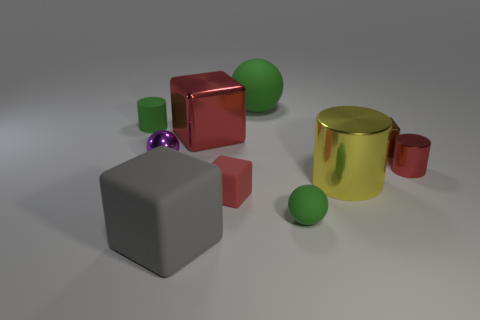How many yellow cylinders are made of the same material as the large gray object?
Provide a succinct answer. 0. There is a green object to the left of the red cube that is in front of the large metal cylinder; how big is it?
Make the answer very short. Small. There is a thing that is both behind the purple metal object and on the left side of the large rubber block; what color is it?
Offer a terse response. Green. Is the shape of the small red metal thing the same as the tiny brown thing?
Your answer should be compact. No. There is a metallic thing that is the same color as the large metallic cube; what size is it?
Your answer should be compact. Small. There is a tiny red object that is on the right side of the big metallic thing that is in front of the small brown cube; what is its shape?
Offer a very short reply. Cylinder. There is a purple thing; is its shape the same as the big rubber object that is in front of the large yellow cylinder?
Ensure brevity in your answer.  No. There is a shiny sphere that is the same size as the brown shiny block; what color is it?
Your answer should be very brief. Purple. Are there fewer small green things that are left of the gray matte cube than small cubes on the left side of the large yellow cylinder?
Provide a succinct answer. No. What is the shape of the metal object that is on the left side of the object in front of the tiny green thing in front of the small brown metallic block?
Offer a terse response. Sphere. 